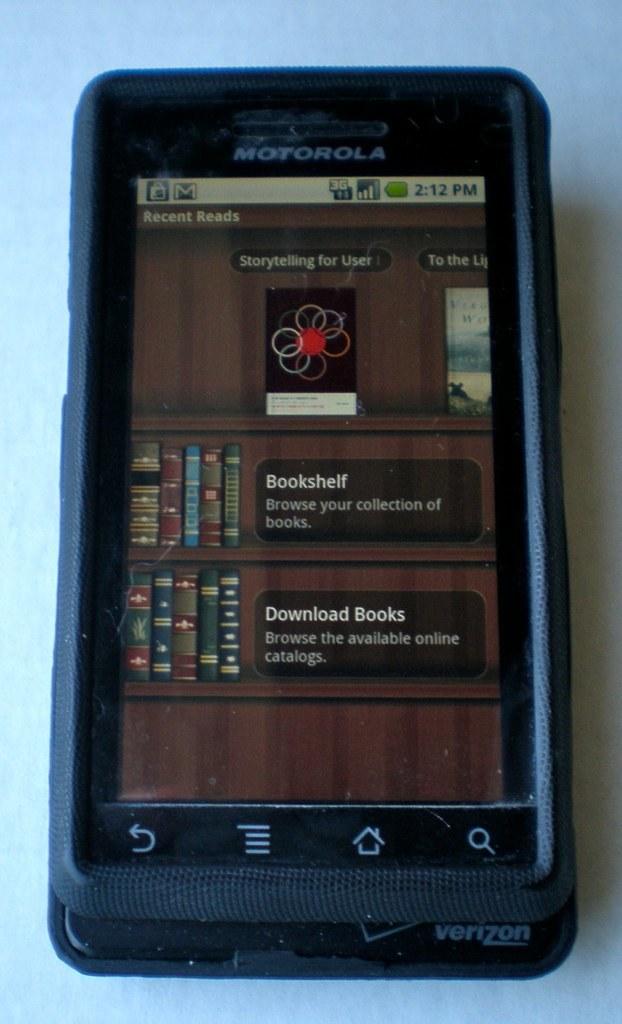What is the time of the photo?
Provide a short and direct response. 2:12. Which phone brand is here?
Give a very brief answer. Motorola. 